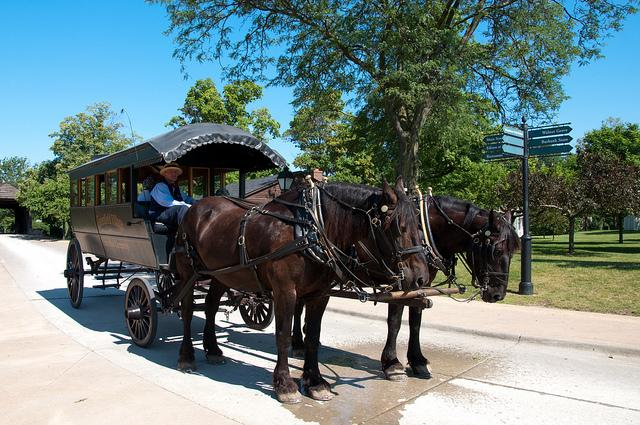What is the green item near the horses?

Choices:
A) grape
B) watermelon
C) sign
D) cucumber sign 